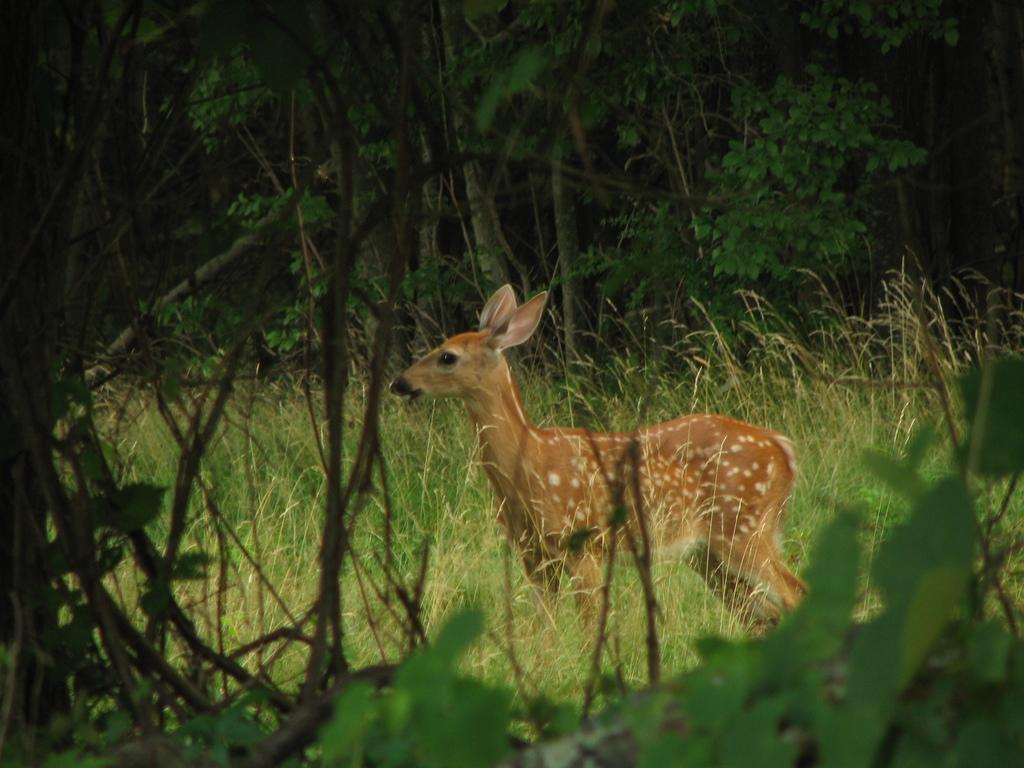What animal is in the center of the image? There is a deer in the center of the image. What can be seen in the background of the image? There are trees in the background of the image. What type of vegetation covers the ground in the image? The ground is covered with grass at the bottom of the image. What type of spark can be seen coming from the deer's antlers in the image? There is no spark present in the image; the deer's antlers are not shown emitting any sparks. 